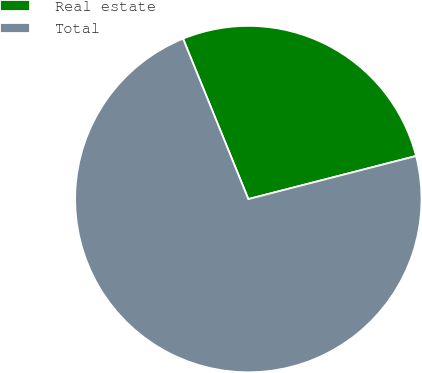Convert chart. <chart><loc_0><loc_0><loc_500><loc_500><pie_chart><fcel>Real estate<fcel>Total<nl><fcel>27.15%<fcel>72.85%<nl></chart> 